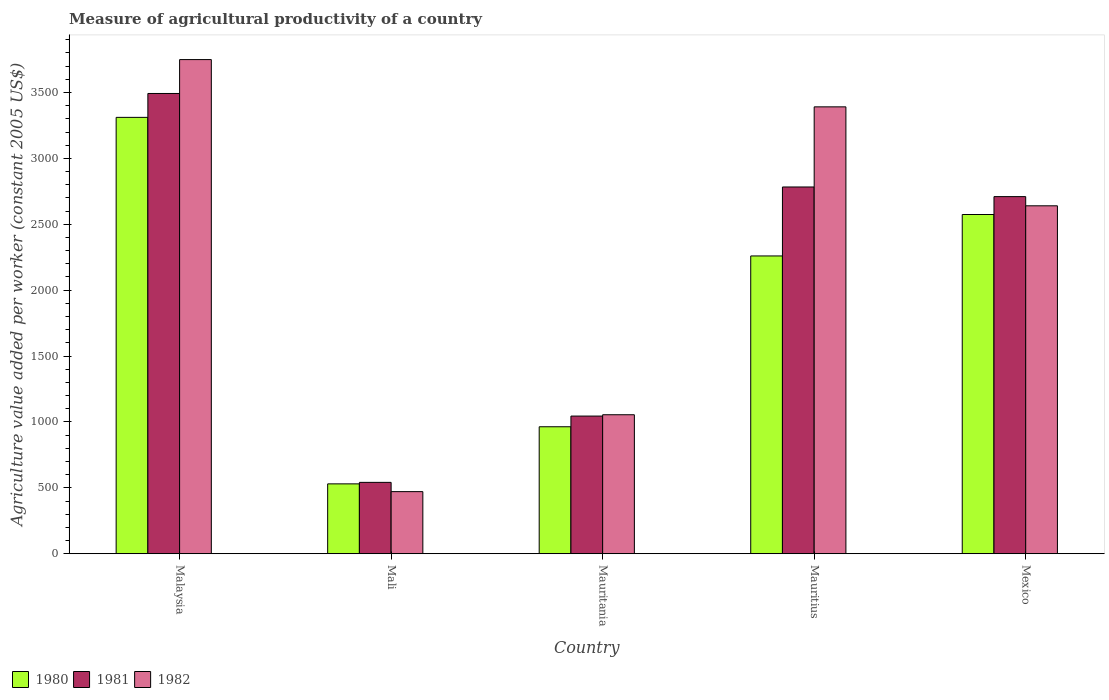How many different coloured bars are there?
Ensure brevity in your answer.  3. Are the number of bars per tick equal to the number of legend labels?
Offer a terse response. Yes. How many bars are there on the 1st tick from the left?
Ensure brevity in your answer.  3. How many bars are there on the 1st tick from the right?
Your response must be concise. 3. What is the label of the 2nd group of bars from the left?
Provide a succinct answer. Mali. What is the measure of agricultural productivity in 1982 in Mexico?
Provide a short and direct response. 2640.27. Across all countries, what is the maximum measure of agricultural productivity in 1982?
Make the answer very short. 3749.8. Across all countries, what is the minimum measure of agricultural productivity in 1981?
Make the answer very short. 541.6. In which country was the measure of agricultural productivity in 1981 maximum?
Your answer should be compact. Malaysia. In which country was the measure of agricultural productivity in 1980 minimum?
Ensure brevity in your answer.  Mali. What is the total measure of agricultural productivity in 1980 in the graph?
Your response must be concise. 9639.16. What is the difference between the measure of agricultural productivity in 1980 in Malaysia and that in Mexico?
Your answer should be very brief. 737.03. What is the difference between the measure of agricultural productivity in 1980 in Mauritania and the measure of agricultural productivity in 1981 in Malaysia?
Give a very brief answer. -2528.96. What is the average measure of agricultural productivity in 1981 per country?
Offer a terse response. 2114.39. What is the difference between the measure of agricultural productivity of/in 1981 and measure of agricultural productivity of/in 1980 in Mali?
Offer a terse response. 11.31. In how many countries, is the measure of agricultural productivity in 1980 greater than 800 US$?
Your response must be concise. 4. What is the ratio of the measure of agricultural productivity in 1980 in Mauritania to that in Mexico?
Your answer should be very brief. 0.37. Is the measure of agricultural productivity in 1981 in Malaysia less than that in Mauritania?
Your answer should be compact. No. Is the difference between the measure of agricultural productivity in 1981 in Mali and Mauritania greater than the difference between the measure of agricultural productivity in 1980 in Mali and Mauritania?
Your answer should be compact. No. What is the difference between the highest and the second highest measure of agricultural productivity in 1981?
Ensure brevity in your answer.  782.66. What is the difference between the highest and the lowest measure of agricultural productivity in 1982?
Your answer should be very brief. 3278.52. Is it the case that in every country, the sum of the measure of agricultural productivity in 1982 and measure of agricultural productivity in 1981 is greater than the measure of agricultural productivity in 1980?
Ensure brevity in your answer.  Yes. How many bars are there?
Your answer should be compact. 15. How many countries are there in the graph?
Make the answer very short. 5. Does the graph contain any zero values?
Give a very brief answer. No. Where does the legend appear in the graph?
Offer a terse response. Bottom left. What is the title of the graph?
Your answer should be very brief. Measure of agricultural productivity of a country. Does "1989" appear as one of the legend labels in the graph?
Provide a succinct answer. No. What is the label or title of the X-axis?
Offer a terse response. Country. What is the label or title of the Y-axis?
Your answer should be compact. Agriculture value added per worker (constant 2005 US$). What is the Agriculture value added per worker (constant 2005 US$) in 1980 in Malaysia?
Your response must be concise. 3311.27. What is the Agriculture value added per worker (constant 2005 US$) of 1981 in Malaysia?
Keep it short and to the point. 3492.6. What is the Agriculture value added per worker (constant 2005 US$) in 1982 in Malaysia?
Provide a succinct answer. 3749.8. What is the Agriculture value added per worker (constant 2005 US$) of 1980 in Mali?
Provide a short and direct response. 530.29. What is the Agriculture value added per worker (constant 2005 US$) of 1981 in Mali?
Your answer should be very brief. 541.6. What is the Agriculture value added per worker (constant 2005 US$) of 1982 in Mali?
Your answer should be compact. 471.28. What is the Agriculture value added per worker (constant 2005 US$) of 1980 in Mauritania?
Offer a very short reply. 963.64. What is the Agriculture value added per worker (constant 2005 US$) of 1981 in Mauritania?
Your response must be concise. 1044.71. What is the Agriculture value added per worker (constant 2005 US$) of 1982 in Mauritania?
Your answer should be compact. 1054.73. What is the Agriculture value added per worker (constant 2005 US$) in 1980 in Mauritius?
Offer a terse response. 2259.73. What is the Agriculture value added per worker (constant 2005 US$) in 1981 in Mauritius?
Provide a succinct answer. 2783.08. What is the Agriculture value added per worker (constant 2005 US$) of 1982 in Mauritius?
Provide a short and direct response. 3391.17. What is the Agriculture value added per worker (constant 2005 US$) in 1980 in Mexico?
Offer a very short reply. 2574.24. What is the Agriculture value added per worker (constant 2005 US$) in 1981 in Mexico?
Provide a short and direct response. 2709.94. What is the Agriculture value added per worker (constant 2005 US$) of 1982 in Mexico?
Give a very brief answer. 2640.27. Across all countries, what is the maximum Agriculture value added per worker (constant 2005 US$) of 1980?
Keep it short and to the point. 3311.27. Across all countries, what is the maximum Agriculture value added per worker (constant 2005 US$) of 1981?
Your answer should be compact. 3492.6. Across all countries, what is the maximum Agriculture value added per worker (constant 2005 US$) in 1982?
Your answer should be very brief. 3749.8. Across all countries, what is the minimum Agriculture value added per worker (constant 2005 US$) of 1980?
Give a very brief answer. 530.29. Across all countries, what is the minimum Agriculture value added per worker (constant 2005 US$) of 1981?
Give a very brief answer. 541.6. Across all countries, what is the minimum Agriculture value added per worker (constant 2005 US$) in 1982?
Keep it short and to the point. 471.28. What is the total Agriculture value added per worker (constant 2005 US$) of 1980 in the graph?
Your answer should be very brief. 9639.16. What is the total Agriculture value added per worker (constant 2005 US$) in 1981 in the graph?
Your answer should be very brief. 1.06e+04. What is the total Agriculture value added per worker (constant 2005 US$) of 1982 in the graph?
Your answer should be very brief. 1.13e+04. What is the difference between the Agriculture value added per worker (constant 2005 US$) of 1980 in Malaysia and that in Mali?
Give a very brief answer. 2780.98. What is the difference between the Agriculture value added per worker (constant 2005 US$) of 1981 in Malaysia and that in Mali?
Give a very brief answer. 2951. What is the difference between the Agriculture value added per worker (constant 2005 US$) in 1982 in Malaysia and that in Mali?
Ensure brevity in your answer.  3278.52. What is the difference between the Agriculture value added per worker (constant 2005 US$) in 1980 in Malaysia and that in Mauritania?
Provide a succinct answer. 2347.63. What is the difference between the Agriculture value added per worker (constant 2005 US$) in 1981 in Malaysia and that in Mauritania?
Offer a very short reply. 2447.9. What is the difference between the Agriculture value added per worker (constant 2005 US$) in 1982 in Malaysia and that in Mauritania?
Your response must be concise. 2695.07. What is the difference between the Agriculture value added per worker (constant 2005 US$) of 1980 in Malaysia and that in Mauritius?
Your answer should be compact. 1051.54. What is the difference between the Agriculture value added per worker (constant 2005 US$) in 1981 in Malaysia and that in Mauritius?
Give a very brief answer. 709.52. What is the difference between the Agriculture value added per worker (constant 2005 US$) in 1982 in Malaysia and that in Mauritius?
Your answer should be compact. 358.63. What is the difference between the Agriculture value added per worker (constant 2005 US$) in 1980 in Malaysia and that in Mexico?
Keep it short and to the point. 737.03. What is the difference between the Agriculture value added per worker (constant 2005 US$) of 1981 in Malaysia and that in Mexico?
Provide a short and direct response. 782.66. What is the difference between the Agriculture value added per worker (constant 2005 US$) in 1982 in Malaysia and that in Mexico?
Make the answer very short. 1109.53. What is the difference between the Agriculture value added per worker (constant 2005 US$) of 1980 in Mali and that in Mauritania?
Give a very brief answer. -433.35. What is the difference between the Agriculture value added per worker (constant 2005 US$) in 1981 in Mali and that in Mauritania?
Your response must be concise. -503.1. What is the difference between the Agriculture value added per worker (constant 2005 US$) of 1982 in Mali and that in Mauritania?
Your response must be concise. -583.45. What is the difference between the Agriculture value added per worker (constant 2005 US$) of 1980 in Mali and that in Mauritius?
Provide a short and direct response. -1729.44. What is the difference between the Agriculture value added per worker (constant 2005 US$) of 1981 in Mali and that in Mauritius?
Offer a terse response. -2241.48. What is the difference between the Agriculture value added per worker (constant 2005 US$) of 1982 in Mali and that in Mauritius?
Offer a terse response. -2919.89. What is the difference between the Agriculture value added per worker (constant 2005 US$) in 1980 in Mali and that in Mexico?
Ensure brevity in your answer.  -2043.95. What is the difference between the Agriculture value added per worker (constant 2005 US$) in 1981 in Mali and that in Mexico?
Your answer should be very brief. -2168.34. What is the difference between the Agriculture value added per worker (constant 2005 US$) of 1982 in Mali and that in Mexico?
Provide a succinct answer. -2168.99. What is the difference between the Agriculture value added per worker (constant 2005 US$) of 1980 in Mauritania and that in Mauritius?
Provide a short and direct response. -1296.09. What is the difference between the Agriculture value added per worker (constant 2005 US$) of 1981 in Mauritania and that in Mauritius?
Offer a very short reply. -1738.38. What is the difference between the Agriculture value added per worker (constant 2005 US$) in 1982 in Mauritania and that in Mauritius?
Offer a terse response. -2336.44. What is the difference between the Agriculture value added per worker (constant 2005 US$) in 1980 in Mauritania and that in Mexico?
Ensure brevity in your answer.  -1610.59. What is the difference between the Agriculture value added per worker (constant 2005 US$) of 1981 in Mauritania and that in Mexico?
Provide a succinct answer. -1665.24. What is the difference between the Agriculture value added per worker (constant 2005 US$) of 1982 in Mauritania and that in Mexico?
Give a very brief answer. -1585.54. What is the difference between the Agriculture value added per worker (constant 2005 US$) of 1980 in Mauritius and that in Mexico?
Provide a short and direct response. -314.51. What is the difference between the Agriculture value added per worker (constant 2005 US$) in 1981 in Mauritius and that in Mexico?
Offer a very short reply. 73.14. What is the difference between the Agriculture value added per worker (constant 2005 US$) of 1982 in Mauritius and that in Mexico?
Provide a short and direct response. 750.9. What is the difference between the Agriculture value added per worker (constant 2005 US$) of 1980 in Malaysia and the Agriculture value added per worker (constant 2005 US$) of 1981 in Mali?
Give a very brief answer. 2769.67. What is the difference between the Agriculture value added per worker (constant 2005 US$) in 1980 in Malaysia and the Agriculture value added per worker (constant 2005 US$) in 1982 in Mali?
Your answer should be very brief. 2839.99. What is the difference between the Agriculture value added per worker (constant 2005 US$) in 1981 in Malaysia and the Agriculture value added per worker (constant 2005 US$) in 1982 in Mali?
Keep it short and to the point. 3021.32. What is the difference between the Agriculture value added per worker (constant 2005 US$) in 1980 in Malaysia and the Agriculture value added per worker (constant 2005 US$) in 1981 in Mauritania?
Offer a very short reply. 2266.57. What is the difference between the Agriculture value added per worker (constant 2005 US$) of 1980 in Malaysia and the Agriculture value added per worker (constant 2005 US$) of 1982 in Mauritania?
Ensure brevity in your answer.  2256.54. What is the difference between the Agriculture value added per worker (constant 2005 US$) in 1981 in Malaysia and the Agriculture value added per worker (constant 2005 US$) in 1982 in Mauritania?
Make the answer very short. 2437.88. What is the difference between the Agriculture value added per worker (constant 2005 US$) of 1980 in Malaysia and the Agriculture value added per worker (constant 2005 US$) of 1981 in Mauritius?
Ensure brevity in your answer.  528.19. What is the difference between the Agriculture value added per worker (constant 2005 US$) of 1980 in Malaysia and the Agriculture value added per worker (constant 2005 US$) of 1982 in Mauritius?
Provide a succinct answer. -79.9. What is the difference between the Agriculture value added per worker (constant 2005 US$) of 1981 in Malaysia and the Agriculture value added per worker (constant 2005 US$) of 1982 in Mauritius?
Ensure brevity in your answer.  101.43. What is the difference between the Agriculture value added per worker (constant 2005 US$) of 1980 in Malaysia and the Agriculture value added per worker (constant 2005 US$) of 1981 in Mexico?
Your answer should be very brief. 601.33. What is the difference between the Agriculture value added per worker (constant 2005 US$) of 1980 in Malaysia and the Agriculture value added per worker (constant 2005 US$) of 1982 in Mexico?
Your response must be concise. 671. What is the difference between the Agriculture value added per worker (constant 2005 US$) of 1981 in Malaysia and the Agriculture value added per worker (constant 2005 US$) of 1982 in Mexico?
Provide a short and direct response. 852.34. What is the difference between the Agriculture value added per worker (constant 2005 US$) of 1980 in Mali and the Agriculture value added per worker (constant 2005 US$) of 1981 in Mauritania?
Your answer should be compact. -514.42. What is the difference between the Agriculture value added per worker (constant 2005 US$) in 1980 in Mali and the Agriculture value added per worker (constant 2005 US$) in 1982 in Mauritania?
Your answer should be compact. -524.44. What is the difference between the Agriculture value added per worker (constant 2005 US$) of 1981 in Mali and the Agriculture value added per worker (constant 2005 US$) of 1982 in Mauritania?
Offer a terse response. -513.12. What is the difference between the Agriculture value added per worker (constant 2005 US$) of 1980 in Mali and the Agriculture value added per worker (constant 2005 US$) of 1981 in Mauritius?
Offer a very short reply. -2252.79. What is the difference between the Agriculture value added per worker (constant 2005 US$) of 1980 in Mali and the Agriculture value added per worker (constant 2005 US$) of 1982 in Mauritius?
Your answer should be very brief. -2860.88. What is the difference between the Agriculture value added per worker (constant 2005 US$) in 1981 in Mali and the Agriculture value added per worker (constant 2005 US$) in 1982 in Mauritius?
Your answer should be very brief. -2849.57. What is the difference between the Agriculture value added per worker (constant 2005 US$) in 1980 in Mali and the Agriculture value added per worker (constant 2005 US$) in 1981 in Mexico?
Offer a terse response. -2179.65. What is the difference between the Agriculture value added per worker (constant 2005 US$) in 1980 in Mali and the Agriculture value added per worker (constant 2005 US$) in 1982 in Mexico?
Provide a short and direct response. -2109.98. What is the difference between the Agriculture value added per worker (constant 2005 US$) in 1981 in Mali and the Agriculture value added per worker (constant 2005 US$) in 1982 in Mexico?
Offer a terse response. -2098.66. What is the difference between the Agriculture value added per worker (constant 2005 US$) of 1980 in Mauritania and the Agriculture value added per worker (constant 2005 US$) of 1981 in Mauritius?
Provide a succinct answer. -1819.44. What is the difference between the Agriculture value added per worker (constant 2005 US$) in 1980 in Mauritania and the Agriculture value added per worker (constant 2005 US$) in 1982 in Mauritius?
Offer a very short reply. -2427.53. What is the difference between the Agriculture value added per worker (constant 2005 US$) of 1981 in Mauritania and the Agriculture value added per worker (constant 2005 US$) of 1982 in Mauritius?
Your answer should be very brief. -2346.46. What is the difference between the Agriculture value added per worker (constant 2005 US$) of 1980 in Mauritania and the Agriculture value added per worker (constant 2005 US$) of 1981 in Mexico?
Keep it short and to the point. -1746.3. What is the difference between the Agriculture value added per worker (constant 2005 US$) in 1980 in Mauritania and the Agriculture value added per worker (constant 2005 US$) in 1982 in Mexico?
Keep it short and to the point. -1676.62. What is the difference between the Agriculture value added per worker (constant 2005 US$) of 1981 in Mauritania and the Agriculture value added per worker (constant 2005 US$) of 1982 in Mexico?
Make the answer very short. -1595.56. What is the difference between the Agriculture value added per worker (constant 2005 US$) of 1980 in Mauritius and the Agriculture value added per worker (constant 2005 US$) of 1981 in Mexico?
Make the answer very short. -450.21. What is the difference between the Agriculture value added per worker (constant 2005 US$) of 1980 in Mauritius and the Agriculture value added per worker (constant 2005 US$) of 1982 in Mexico?
Make the answer very short. -380.54. What is the difference between the Agriculture value added per worker (constant 2005 US$) of 1981 in Mauritius and the Agriculture value added per worker (constant 2005 US$) of 1982 in Mexico?
Give a very brief answer. 142.82. What is the average Agriculture value added per worker (constant 2005 US$) in 1980 per country?
Provide a succinct answer. 1927.83. What is the average Agriculture value added per worker (constant 2005 US$) of 1981 per country?
Offer a very short reply. 2114.39. What is the average Agriculture value added per worker (constant 2005 US$) in 1982 per country?
Your answer should be compact. 2261.45. What is the difference between the Agriculture value added per worker (constant 2005 US$) in 1980 and Agriculture value added per worker (constant 2005 US$) in 1981 in Malaysia?
Keep it short and to the point. -181.33. What is the difference between the Agriculture value added per worker (constant 2005 US$) of 1980 and Agriculture value added per worker (constant 2005 US$) of 1982 in Malaysia?
Provide a short and direct response. -438.53. What is the difference between the Agriculture value added per worker (constant 2005 US$) in 1981 and Agriculture value added per worker (constant 2005 US$) in 1982 in Malaysia?
Your answer should be compact. -257.2. What is the difference between the Agriculture value added per worker (constant 2005 US$) of 1980 and Agriculture value added per worker (constant 2005 US$) of 1981 in Mali?
Provide a succinct answer. -11.31. What is the difference between the Agriculture value added per worker (constant 2005 US$) in 1980 and Agriculture value added per worker (constant 2005 US$) in 1982 in Mali?
Your response must be concise. 59.01. What is the difference between the Agriculture value added per worker (constant 2005 US$) in 1981 and Agriculture value added per worker (constant 2005 US$) in 1982 in Mali?
Make the answer very short. 70.33. What is the difference between the Agriculture value added per worker (constant 2005 US$) of 1980 and Agriculture value added per worker (constant 2005 US$) of 1981 in Mauritania?
Give a very brief answer. -81.06. What is the difference between the Agriculture value added per worker (constant 2005 US$) in 1980 and Agriculture value added per worker (constant 2005 US$) in 1982 in Mauritania?
Your answer should be very brief. -91.08. What is the difference between the Agriculture value added per worker (constant 2005 US$) of 1981 and Agriculture value added per worker (constant 2005 US$) of 1982 in Mauritania?
Offer a very short reply. -10.02. What is the difference between the Agriculture value added per worker (constant 2005 US$) in 1980 and Agriculture value added per worker (constant 2005 US$) in 1981 in Mauritius?
Keep it short and to the point. -523.35. What is the difference between the Agriculture value added per worker (constant 2005 US$) in 1980 and Agriculture value added per worker (constant 2005 US$) in 1982 in Mauritius?
Ensure brevity in your answer.  -1131.44. What is the difference between the Agriculture value added per worker (constant 2005 US$) of 1981 and Agriculture value added per worker (constant 2005 US$) of 1982 in Mauritius?
Your answer should be very brief. -608.09. What is the difference between the Agriculture value added per worker (constant 2005 US$) in 1980 and Agriculture value added per worker (constant 2005 US$) in 1981 in Mexico?
Offer a terse response. -135.71. What is the difference between the Agriculture value added per worker (constant 2005 US$) of 1980 and Agriculture value added per worker (constant 2005 US$) of 1982 in Mexico?
Offer a terse response. -66.03. What is the difference between the Agriculture value added per worker (constant 2005 US$) of 1981 and Agriculture value added per worker (constant 2005 US$) of 1982 in Mexico?
Ensure brevity in your answer.  69.68. What is the ratio of the Agriculture value added per worker (constant 2005 US$) in 1980 in Malaysia to that in Mali?
Give a very brief answer. 6.24. What is the ratio of the Agriculture value added per worker (constant 2005 US$) of 1981 in Malaysia to that in Mali?
Give a very brief answer. 6.45. What is the ratio of the Agriculture value added per worker (constant 2005 US$) in 1982 in Malaysia to that in Mali?
Provide a succinct answer. 7.96. What is the ratio of the Agriculture value added per worker (constant 2005 US$) of 1980 in Malaysia to that in Mauritania?
Offer a very short reply. 3.44. What is the ratio of the Agriculture value added per worker (constant 2005 US$) of 1981 in Malaysia to that in Mauritania?
Give a very brief answer. 3.34. What is the ratio of the Agriculture value added per worker (constant 2005 US$) in 1982 in Malaysia to that in Mauritania?
Keep it short and to the point. 3.56. What is the ratio of the Agriculture value added per worker (constant 2005 US$) of 1980 in Malaysia to that in Mauritius?
Your answer should be compact. 1.47. What is the ratio of the Agriculture value added per worker (constant 2005 US$) in 1981 in Malaysia to that in Mauritius?
Your answer should be compact. 1.25. What is the ratio of the Agriculture value added per worker (constant 2005 US$) in 1982 in Malaysia to that in Mauritius?
Your answer should be very brief. 1.11. What is the ratio of the Agriculture value added per worker (constant 2005 US$) in 1980 in Malaysia to that in Mexico?
Provide a succinct answer. 1.29. What is the ratio of the Agriculture value added per worker (constant 2005 US$) in 1981 in Malaysia to that in Mexico?
Keep it short and to the point. 1.29. What is the ratio of the Agriculture value added per worker (constant 2005 US$) of 1982 in Malaysia to that in Mexico?
Offer a terse response. 1.42. What is the ratio of the Agriculture value added per worker (constant 2005 US$) in 1980 in Mali to that in Mauritania?
Your answer should be compact. 0.55. What is the ratio of the Agriculture value added per worker (constant 2005 US$) in 1981 in Mali to that in Mauritania?
Ensure brevity in your answer.  0.52. What is the ratio of the Agriculture value added per worker (constant 2005 US$) of 1982 in Mali to that in Mauritania?
Provide a short and direct response. 0.45. What is the ratio of the Agriculture value added per worker (constant 2005 US$) in 1980 in Mali to that in Mauritius?
Keep it short and to the point. 0.23. What is the ratio of the Agriculture value added per worker (constant 2005 US$) in 1981 in Mali to that in Mauritius?
Make the answer very short. 0.19. What is the ratio of the Agriculture value added per worker (constant 2005 US$) in 1982 in Mali to that in Mauritius?
Offer a very short reply. 0.14. What is the ratio of the Agriculture value added per worker (constant 2005 US$) of 1980 in Mali to that in Mexico?
Your answer should be compact. 0.21. What is the ratio of the Agriculture value added per worker (constant 2005 US$) of 1981 in Mali to that in Mexico?
Your response must be concise. 0.2. What is the ratio of the Agriculture value added per worker (constant 2005 US$) in 1982 in Mali to that in Mexico?
Your response must be concise. 0.18. What is the ratio of the Agriculture value added per worker (constant 2005 US$) in 1980 in Mauritania to that in Mauritius?
Ensure brevity in your answer.  0.43. What is the ratio of the Agriculture value added per worker (constant 2005 US$) in 1981 in Mauritania to that in Mauritius?
Your answer should be very brief. 0.38. What is the ratio of the Agriculture value added per worker (constant 2005 US$) of 1982 in Mauritania to that in Mauritius?
Your answer should be compact. 0.31. What is the ratio of the Agriculture value added per worker (constant 2005 US$) in 1980 in Mauritania to that in Mexico?
Ensure brevity in your answer.  0.37. What is the ratio of the Agriculture value added per worker (constant 2005 US$) of 1981 in Mauritania to that in Mexico?
Offer a very short reply. 0.39. What is the ratio of the Agriculture value added per worker (constant 2005 US$) in 1982 in Mauritania to that in Mexico?
Ensure brevity in your answer.  0.4. What is the ratio of the Agriculture value added per worker (constant 2005 US$) in 1980 in Mauritius to that in Mexico?
Ensure brevity in your answer.  0.88. What is the ratio of the Agriculture value added per worker (constant 2005 US$) of 1982 in Mauritius to that in Mexico?
Provide a short and direct response. 1.28. What is the difference between the highest and the second highest Agriculture value added per worker (constant 2005 US$) of 1980?
Your answer should be compact. 737.03. What is the difference between the highest and the second highest Agriculture value added per worker (constant 2005 US$) in 1981?
Your answer should be compact. 709.52. What is the difference between the highest and the second highest Agriculture value added per worker (constant 2005 US$) in 1982?
Provide a succinct answer. 358.63. What is the difference between the highest and the lowest Agriculture value added per worker (constant 2005 US$) of 1980?
Make the answer very short. 2780.98. What is the difference between the highest and the lowest Agriculture value added per worker (constant 2005 US$) of 1981?
Your response must be concise. 2951. What is the difference between the highest and the lowest Agriculture value added per worker (constant 2005 US$) in 1982?
Your response must be concise. 3278.52. 